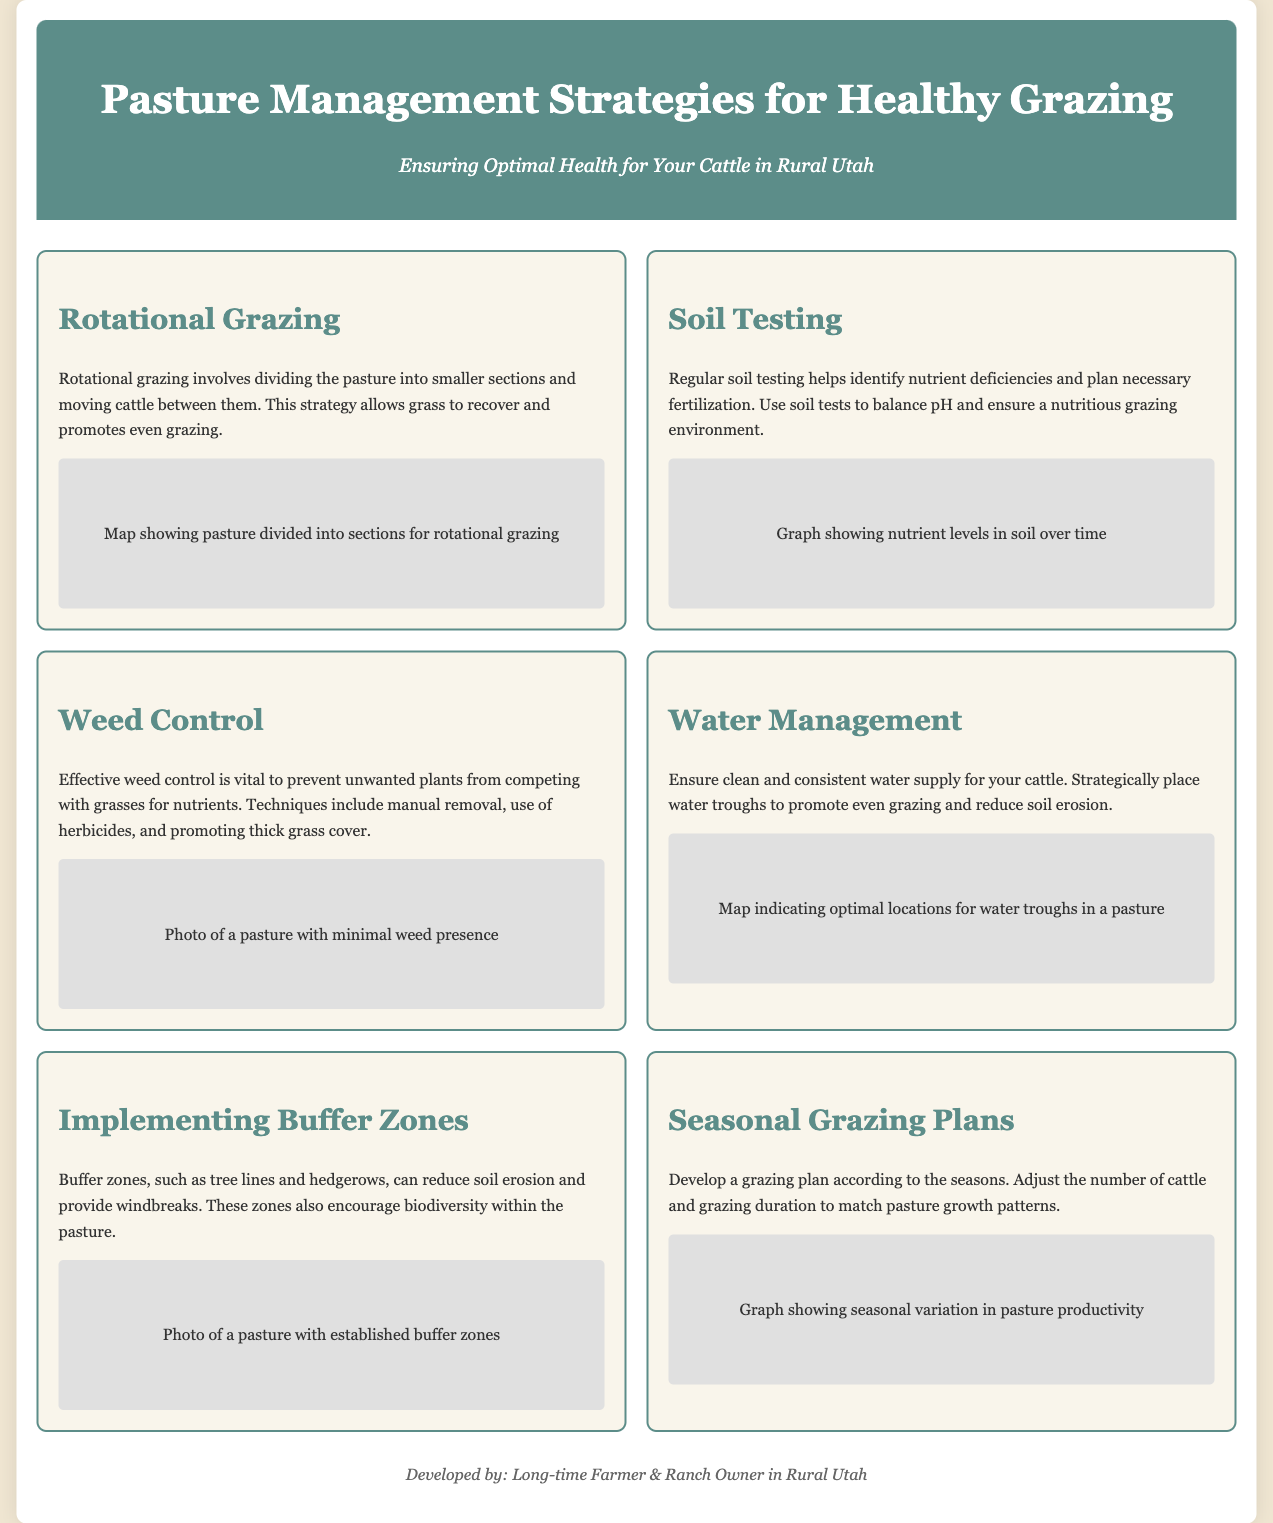what is the title of the infographic? The title of the infographic is prominently displayed at the top of the document.
Answer: Pasture Management Strategies for Healthy Grazing what grazing strategy is described that involves moving cattle between sections? The infographic explains a strategy where cattle are divided into smaller sections for grazing.
Answer: Rotational Grazing what is the purpose of soil testing mentioned in the infographic? Soil testing is mentioned as a method for identifying nutrient deficiencies to improve grazing conditions.
Answer: Identify nutrient deficiencies what visual aid accompanies the weed control section? The infographic provides a visual aid that showcases the effectiveness of controlling weeds in pastures.
Answer: Photo of a pasture with minimal weed presence how do buffer zones benefit pastures according to the document? The document states the advantages of incorporating buffer zones in pasture management.
Answer: Reduce soil erosion what should be adjusted according to seasonal grazing plans? The infographic suggests modifications need to be made based on the seasonal patterns affecting pastures.
Answer: Number of cattle and grazing duration what color is the header background in the infographic? The document includes a description of the color used in the header section.
Answer: Dark green what does the visual aid in the water management section represent? The infographic highlights the strategic placement of water sources for grazing management through a specific type of visual.
Answer: Map indicating optimal locations for water troughs in a pasture 